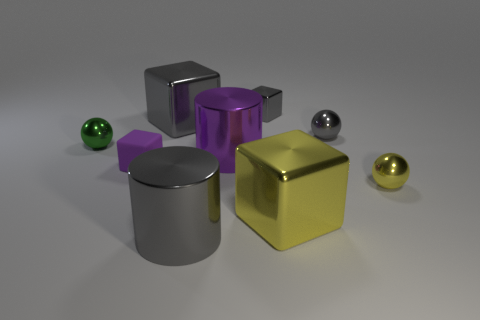Add 1 tiny gray balls. How many objects exist? 10 Subtract all blocks. How many objects are left? 5 Subtract all gray balls. Subtract all gray matte things. How many objects are left? 8 Add 4 green things. How many green things are left? 5 Add 5 tiny purple things. How many tiny purple things exist? 6 Subtract 0 blue cubes. How many objects are left? 9 